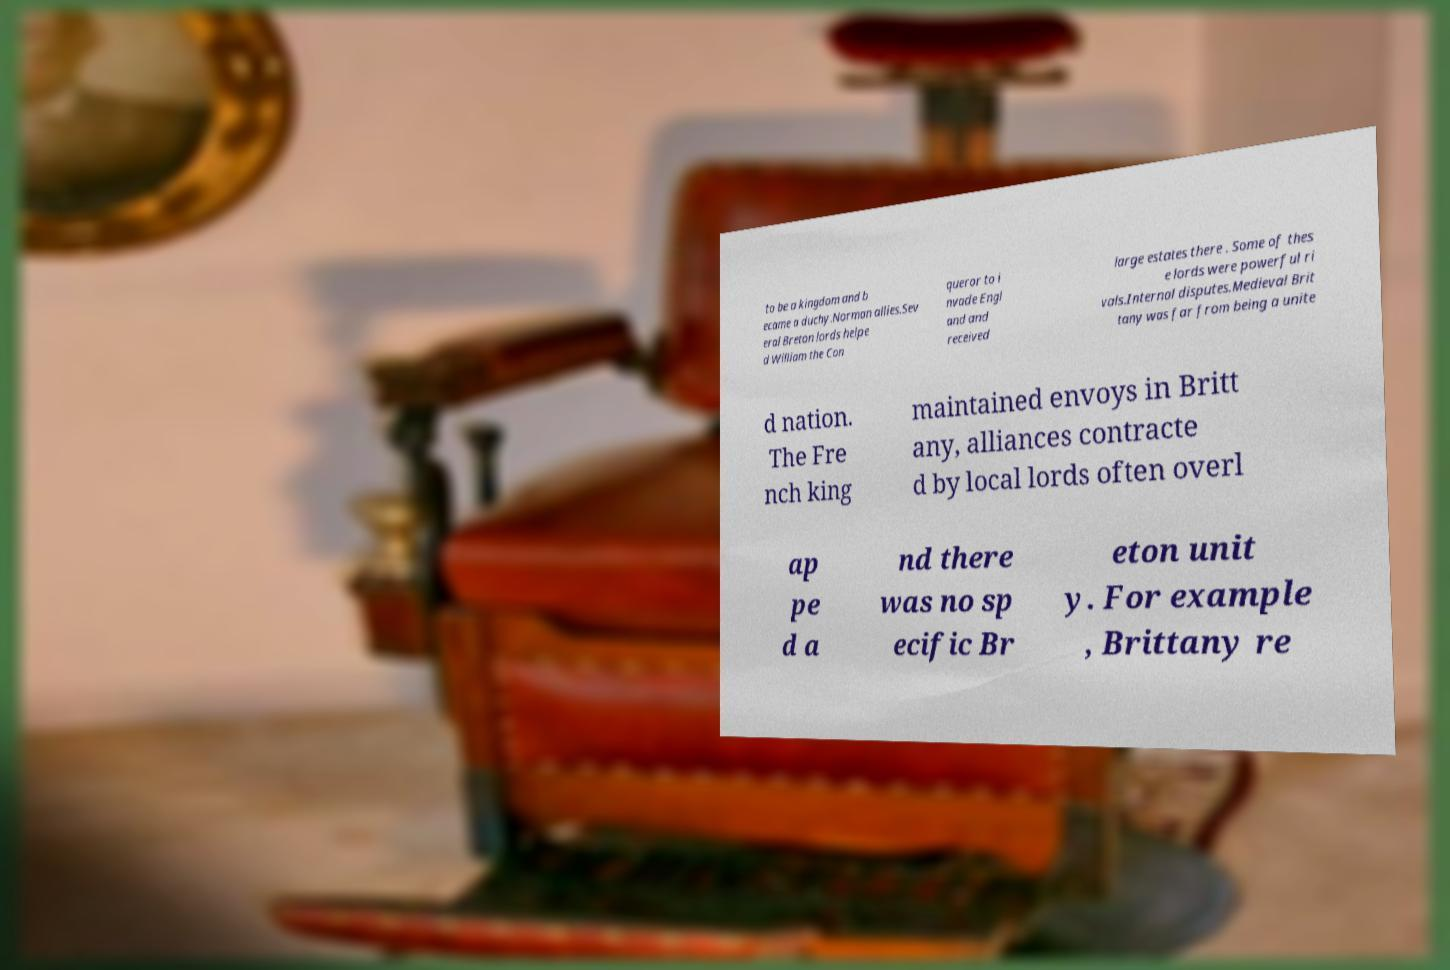What messages or text are displayed in this image? I need them in a readable, typed format. to be a kingdom and b ecame a duchy.Norman allies.Sev eral Breton lords helpe d William the Con queror to i nvade Engl and and received large estates there . Some of thes e lords were powerful ri vals.Internal disputes.Medieval Brit tany was far from being a unite d nation. The Fre nch king maintained envoys in Britt any, alliances contracte d by local lords often overl ap pe d a nd there was no sp ecific Br eton unit y. For example , Brittany re 